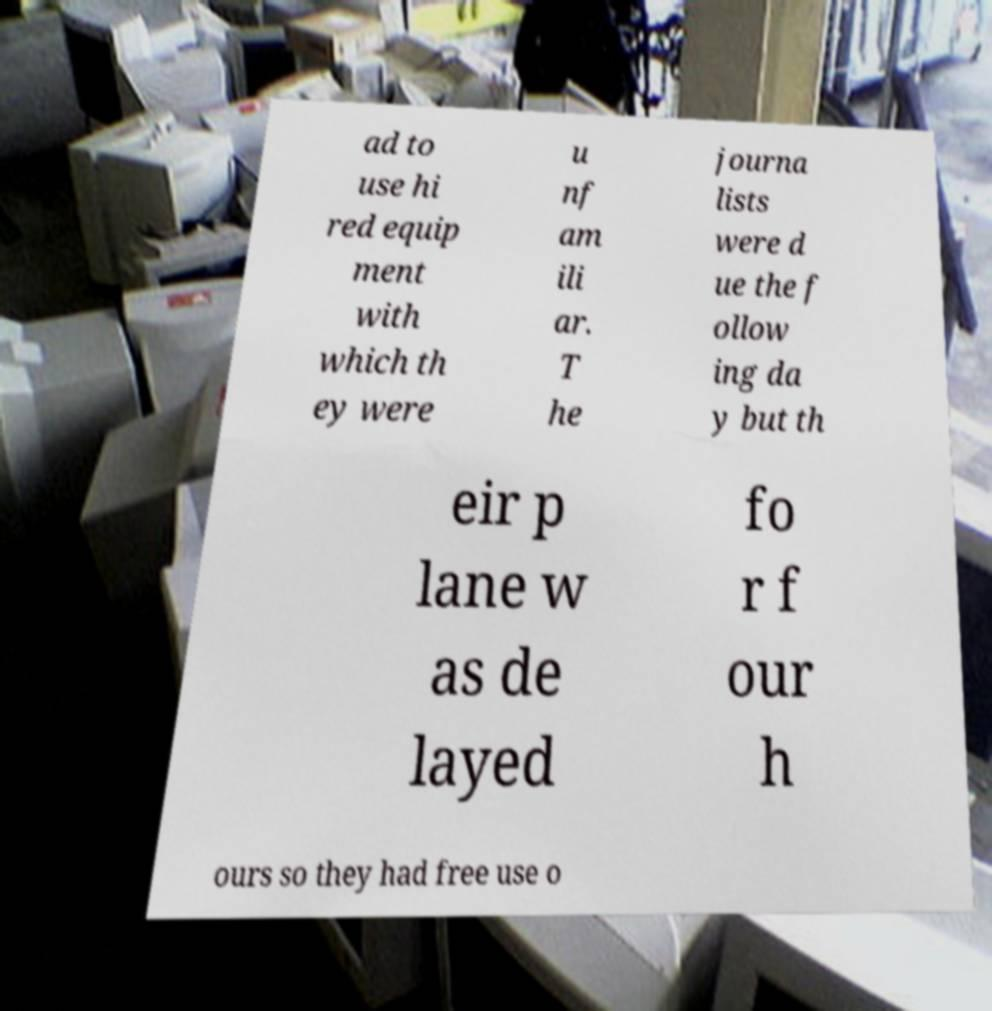I need the written content from this picture converted into text. Can you do that? ad to use hi red equip ment with which th ey were u nf am ili ar. T he journa lists were d ue the f ollow ing da y but th eir p lane w as de layed fo r f our h ours so they had free use o 